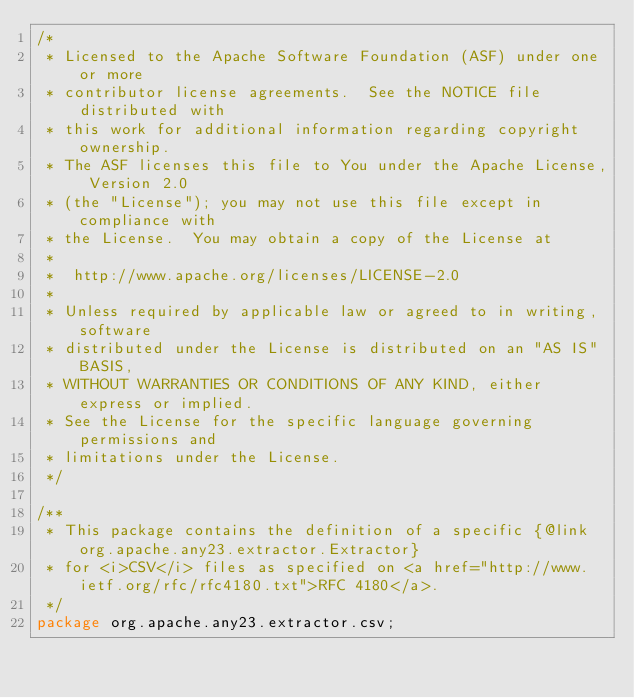<code> <loc_0><loc_0><loc_500><loc_500><_Java_>/*
 * Licensed to the Apache Software Foundation (ASF) under one or more
 * contributor license agreements.  See the NOTICE file distributed with
 * this work for additional information regarding copyright ownership.
 * The ASF licenses this file to You under the Apache License, Version 2.0
 * (the "License"); you may not use this file except in compliance with
 * the License.  You may obtain a copy of the License at
 *
 *  http://www.apache.org/licenses/LICENSE-2.0
 *
 * Unless required by applicable law or agreed to in writing, software
 * distributed under the License is distributed on an "AS IS" BASIS,
 * WITHOUT WARRANTIES OR CONDITIONS OF ANY KIND, either express or implied.
 * See the License for the specific language governing permissions and
 * limitations under the License.
 */

/**
 * This package contains the definition of a specific {@link org.apache.any23.extractor.Extractor}
 * for <i>CSV</i> files as specified on <a href="http://www.ietf.org/rfc/rfc4180.txt">RFC 4180</a>.
 */
package org.apache.any23.extractor.csv;</code> 